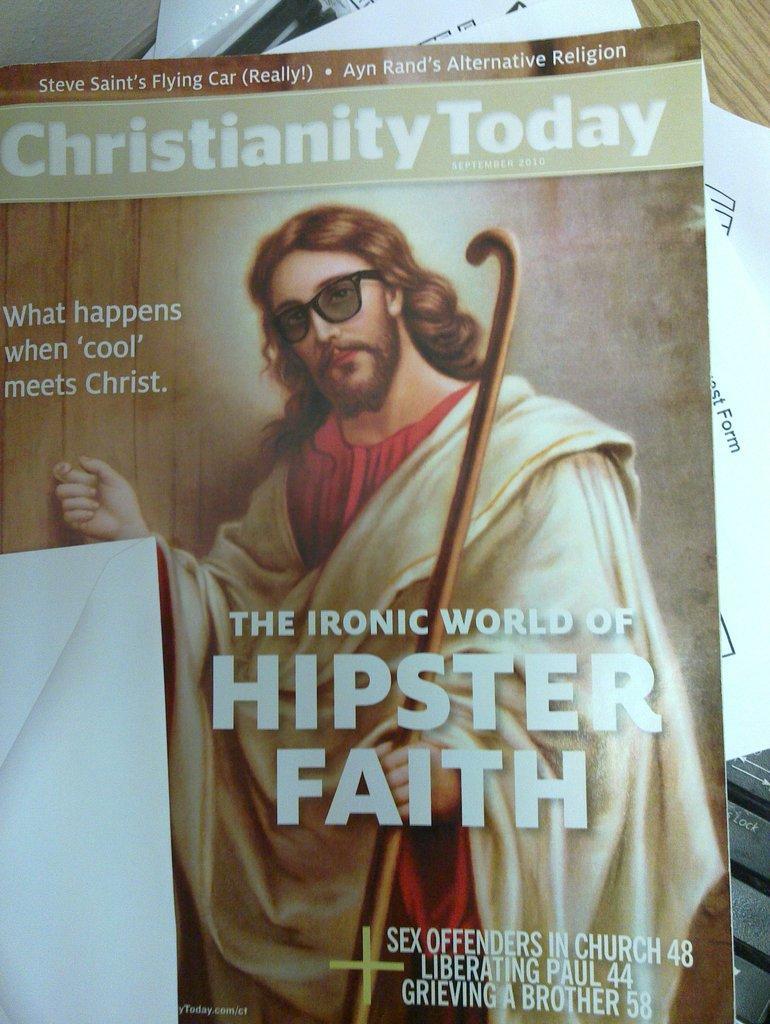Please provide a concise description of this image. In this image I can see a book. The cover page of the book contains a picture of a person holding a stick and some text is written on it. There are papers and a keyboard below the book. 